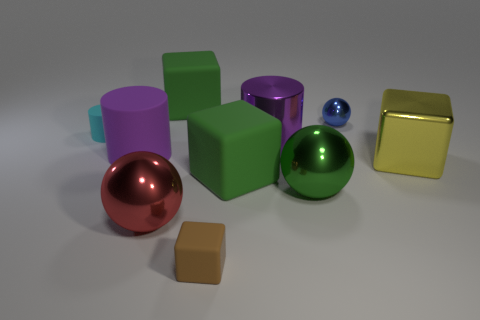Subtract all green cubes. How many were subtracted if there are1green cubes left? 1 Subtract 1 blocks. How many blocks are left? 3 Subtract all gray spheres. Subtract all gray blocks. How many spheres are left? 3 Subtract all yellow balls. How many green blocks are left? 2 Subtract all big green metallic objects. Subtract all green shiny balls. How many objects are left? 8 Add 8 large matte blocks. How many large matte blocks are left? 10 Add 9 large purple matte cylinders. How many large purple matte cylinders exist? 10 Subtract all green cubes. How many cubes are left? 2 Subtract all big spheres. How many spheres are left? 1 Subtract 1 green balls. How many objects are left? 9 